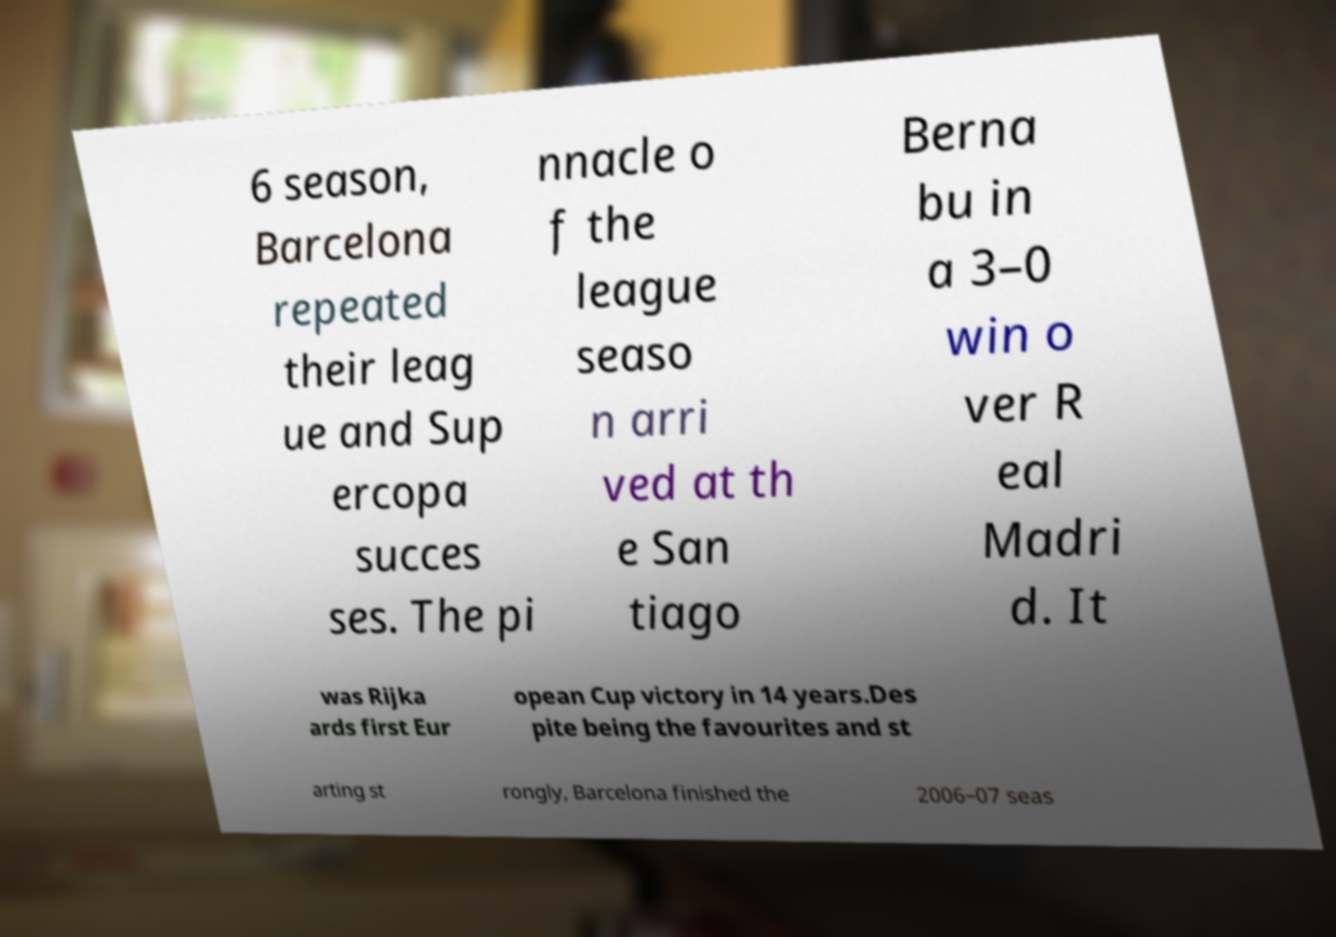Can you accurately transcribe the text from the provided image for me? 6 season, Barcelona repeated their leag ue and Sup ercopa succes ses. The pi nnacle o f the league seaso n arri ved at th e San tiago Berna bu in a 3–0 win o ver R eal Madri d. It was Rijka ards first Eur opean Cup victory in 14 years.Des pite being the favourites and st arting st rongly, Barcelona finished the 2006–07 seas 